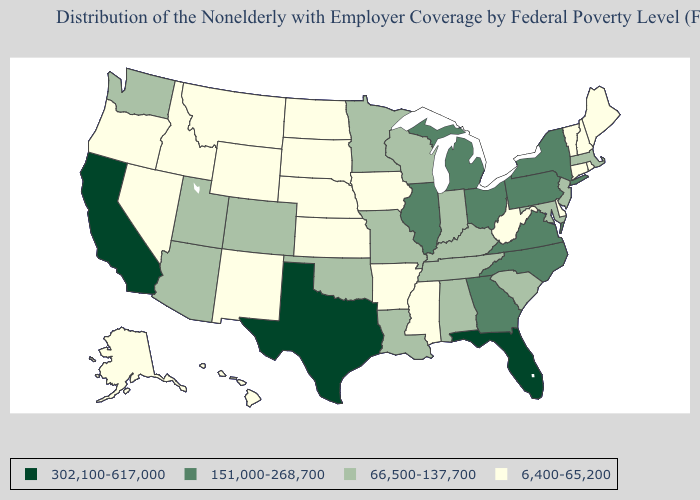What is the value of Florida?
Be succinct. 302,100-617,000. Among the states that border Tennessee , which have the highest value?
Concise answer only. Georgia, North Carolina, Virginia. Which states have the lowest value in the West?
Be succinct. Alaska, Hawaii, Idaho, Montana, Nevada, New Mexico, Oregon, Wyoming. Name the states that have a value in the range 151,000-268,700?
Short answer required. Georgia, Illinois, Michigan, New York, North Carolina, Ohio, Pennsylvania, Virginia. Among the states that border North Dakota , which have the highest value?
Write a very short answer. Minnesota. Name the states that have a value in the range 6,400-65,200?
Short answer required. Alaska, Arkansas, Connecticut, Delaware, Hawaii, Idaho, Iowa, Kansas, Maine, Mississippi, Montana, Nebraska, Nevada, New Hampshire, New Mexico, North Dakota, Oregon, Rhode Island, South Dakota, Vermont, West Virginia, Wyoming. Name the states that have a value in the range 6,400-65,200?
Short answer required. Alaska, Arkansas, Connecticut, Delaware, Hawaii, Idaho, Iowa, Kansas, Maine, Mississippi, Montana, Nebraska, Nevada, New Hampshire, New Mexico, North Dakota, Oregon, Rhode Island, South Dakota, Vermont, West Virginia, Wyoming. What is the lowest value in the MidWest?
Write a very short answer. 6,400-65,200. What is the value of Florida?
Short answer required. 302,100-617,000. Does Iowa have a lower value than Arkansas?
Answer briefly. No. Name the states that have a value in the range 6,400-65,200?
Be succinct. Alaska, Arkansas, Connecticut, Delaware, Hawaii, Idaho, Iowa, Kansas, Maine, Mississippi, Montana, Nebraska, Nevada, New Hampshire, New Mexico, North Dakota, Oregon, Rhode Island, South Dakota, Vermont, West Virginia, Wyoming. Name the states that have a value in the range 66,500-137,700?
Be succinct. Alabama, Arizona, Colorado, Indiana, Kentucky, Louisiana, Maryland, Massachusetts, Minnesota, Missouri, New Jersey, Oklahoma, South Carolina, Tennessee, Utah, Washington, Wisconsin. Among the states that border Indiana , which have the highest value?
Quick response, please. Illinois, Michigan, Ohio. Is the legend a continuous bar?
Short answer required. No. What is the highest value in the West ?
Answer briefly. 302,100-617,000. 